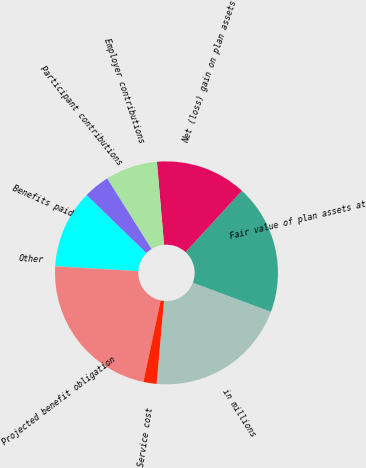Convert chart. <chart><loc_0><loc_0><loc_500><loc_500><pie_chart><fcel>in millions<fcel>Fair value of plan assets at<fcel>Net (loss) gain on plan assets<fcel>Employer contributions<fcel>Participant contributions<fcel>Benefits paid<fcel>Other<fcel>Projected benefit obligation<fcel>Service cost<nl><fcel>20.73%<fcel>18.85%<fcel>13.2%<fcel>7.56%<fcel>3.79%<fcel>11.32%<fcel>0.03%<fcel>22.61%<fcel>1.91%<nl></chart> 